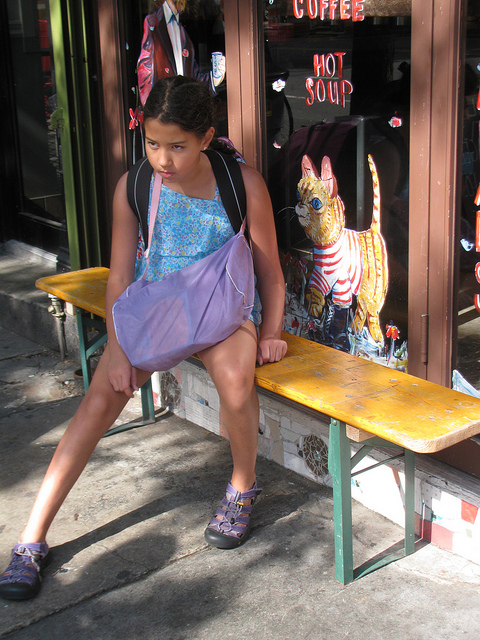Please identify all text content in this image. COFFEE HOT Soup 